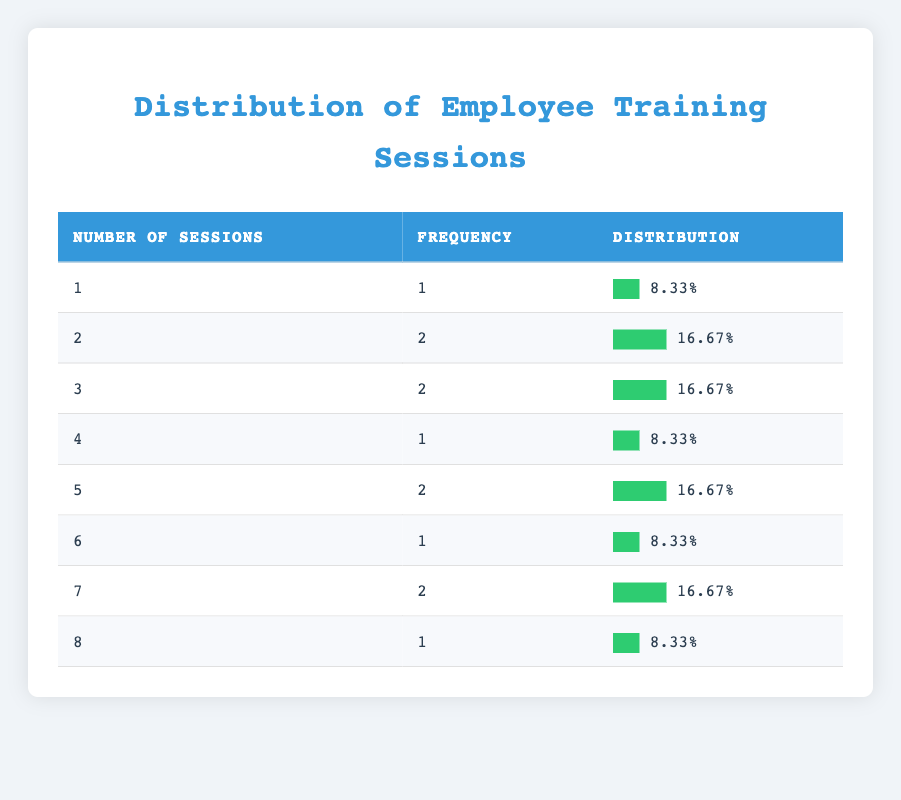What is the frequency of employees who attended 6 training sessions? From the table, we can see that for 6 training sessions, the frequency listed is 1. This means there is one employee who attended 6 training sessions.
Answer: 1 How many employees attended at least 5 training sessions? Looking at the table, the counts of sessions attended for 5, 6, 7, and 8 are 2, 1, 2, and 1 respectively. Adding these together gives 2 + 1 + 2 + 1 = 6. Therefore, 6 employees attended at least 5 sessions.
Answer: 6 What percentage of employees attended only 1 training session? The frequency for employees who attended only 1 session is 1. There are a total of 12 employees. To find the percentage, we calculate (1/12) * 100 = 8.33%.
Answer: 8.33% Is there a training session attendance of 4 sessions? Referring to the table, there is a frequency of 1 employee who attended 4 sessions. This confirms that yes, there is at least one employee with this attendance record.
Answer: Yes Calculate the average number of training sessions attended by employees. To find the average, first, multiply the number of sessions by their respective frequencies: (1\*1) + (2\*2) + (3\*2) + (4\*1) + (5\*2) + (6\*1) + (7\*2) + (8\*1) = 1 + 4 + 6 + 4 + 10 + 6 + 14 + 8 = 53. Then, divide by the total number of employees (12): 53/12 = 4.42. The average is thus approximately 4.42.
Answer: 4.42 How many employees attended a total of 3 or more training sessions? The frequencies for 3 sessions and above are for 3 sessions: 2, 4 sessions: 1, 5 sessions: 2, 6 sessions: 1, 7 sessions: 2, and 8 sessions: 1. Adding these frequencies gives 2 + 1 + 2 + 1 + 2 + 1 = 9 employees in total attended 3 or more training sessions.
Answer: 9 